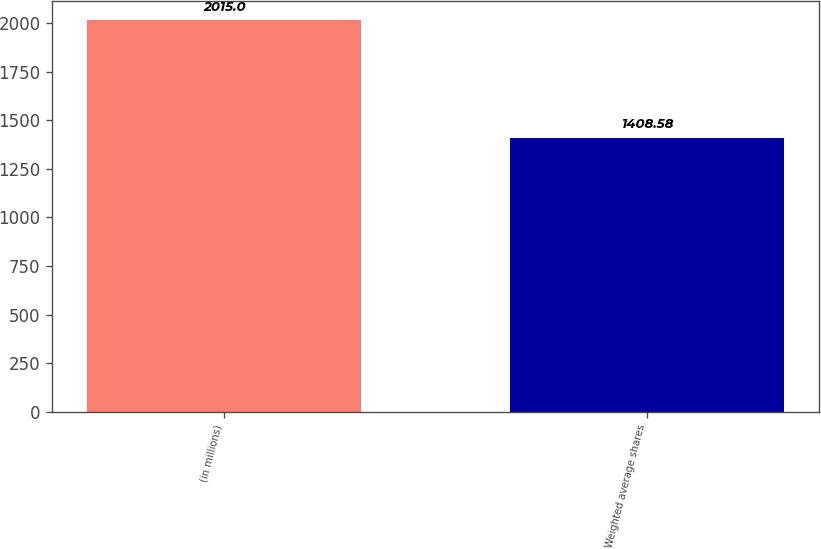<chart> <loc_0><loc_0><loc_500><loc_500><bar_chart><fcel>(in millions)<fcel>Weighted average shares<nl><fcel>2015<fcel>1408.58<nl></chart> 